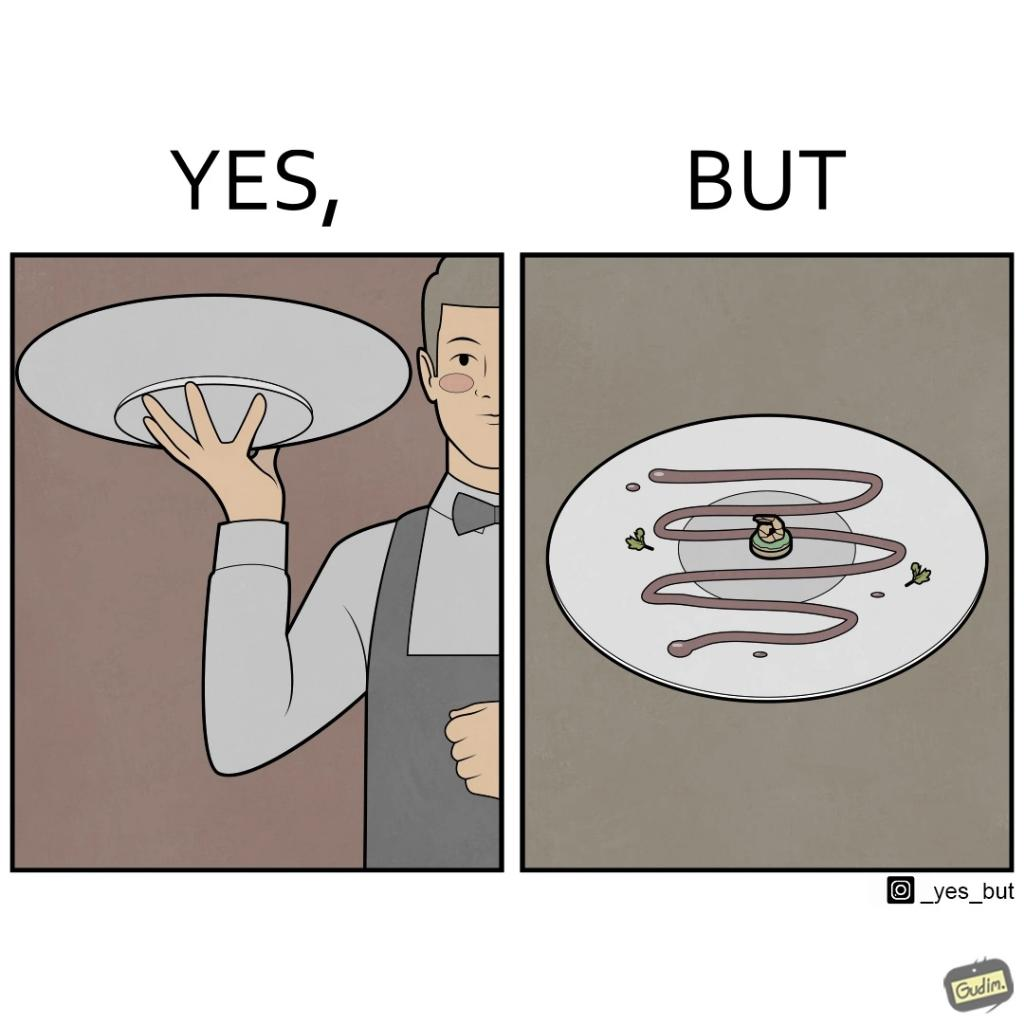Describe the satirical element in this image. The image is ironic, because  in the first image the waiter is bringing the dish to the table presenting it as some lavish dish but in the second image when the dish is shown in the plate its just a small piece to eat 